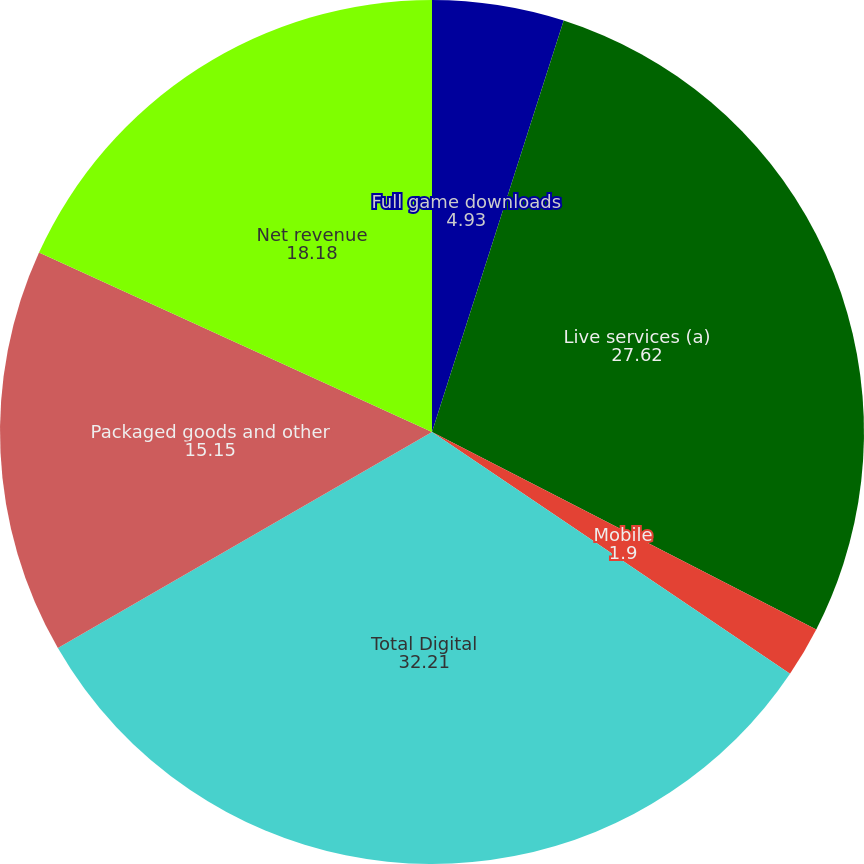<chart> <loc_0><loc_0><loc_500><loc_500><pie_chart><fcel>Full game downloads<fcel>Live services (a)<fcel>Mobile<fcel>Total Digital<fcel>Packaged goods and other<fcel>Net revenue<nl><fcel>4.93%<fcel>27.62%<fcel>1.9%<fcel>32.21%<fcel>15.15%<fcel>18.18%<nl></chart> 